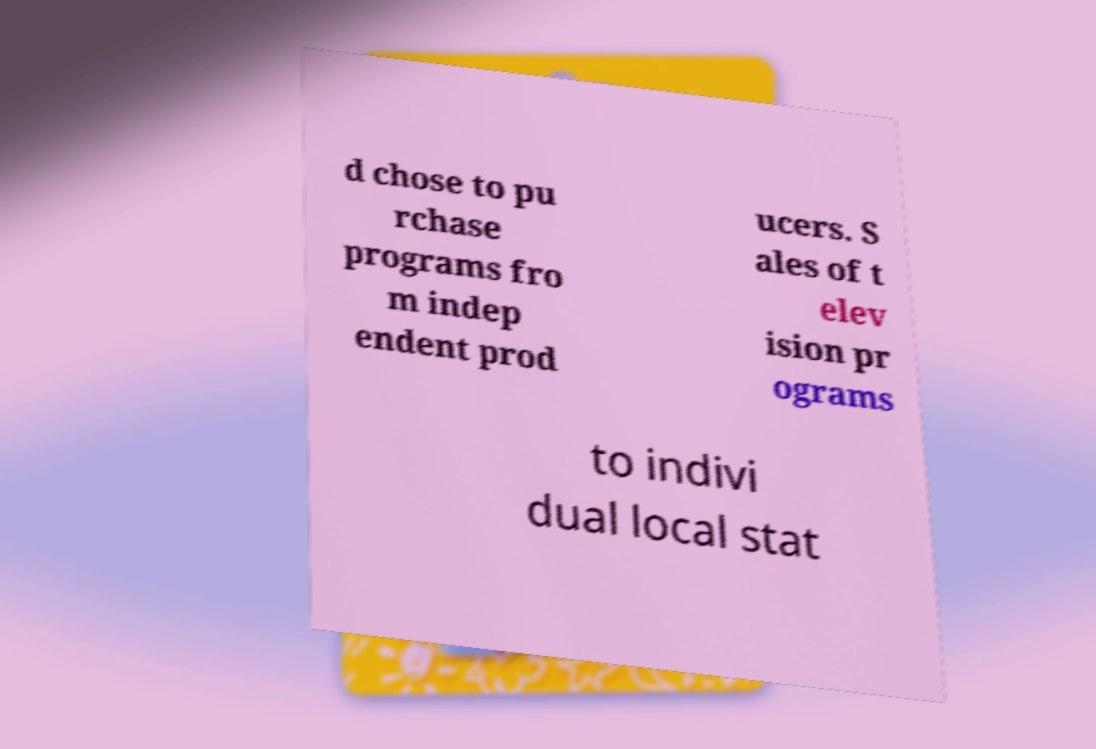There's text embedded in this image that I need extracted. Can you transcribe it verbatim? d chose to pu rchase programs fro m indep endent prod ucers. S ales of t elev ision pr ograms to indivi dual local stat 